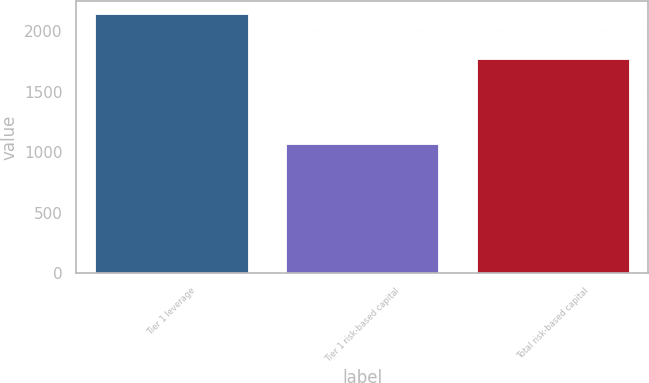<chart> <loc_0><loc_0><loc_500><loc_500><bar_chart><fcel>Tier 1 leverage<fcel>Tier 1 risk-based capital<fcel>Total risk-based capital<nl><fcel>2143<fcel>1063<fcel>1772<nl></chart> 